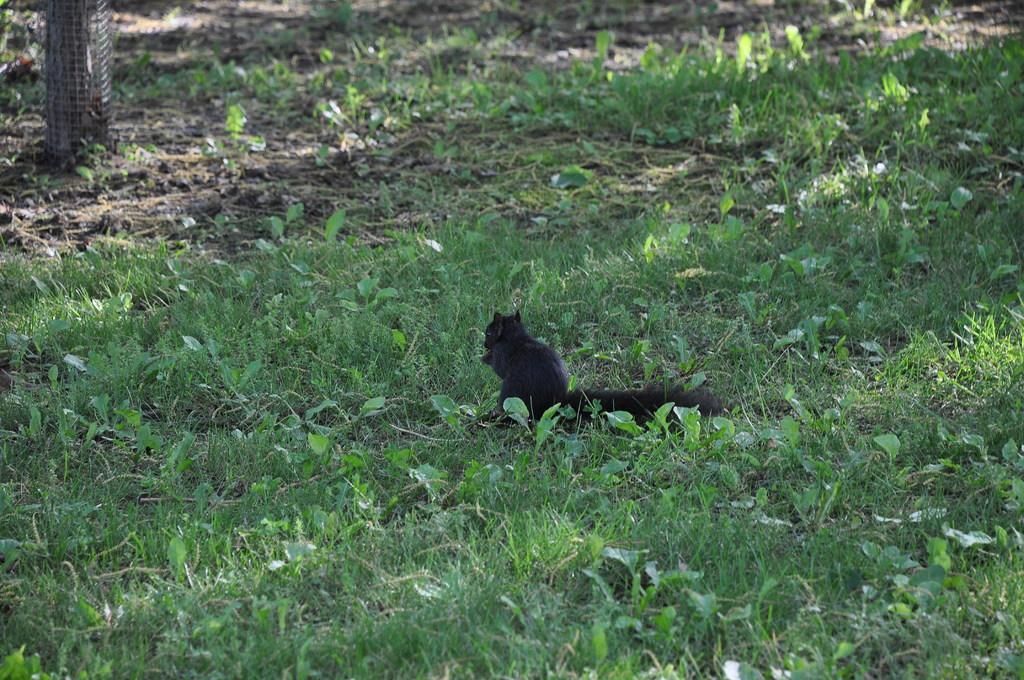In one or two sentences, can you explain what this image depicts? There is an animal sitting on the grass. On the left at the top corner there is an object. 